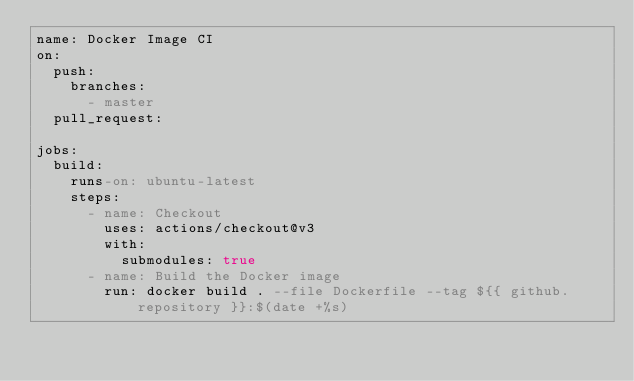<code> <loc_0><loc_0><loc_500><loc_500><_YAML_>name: Docker Image CI
on:
  push:
    branches:
      - master
  pull_request:

jobs:
  build:
    runs-on: ubuntu-latest
    steps:
      - name: Checkout
        uses: actions/checkout@v3
        with:
          submodules: true
      - name: Build the Docker image
        run: docker build . --file Dockerfile --tag ${{ github.repository }}:$(date +%s)
</code> 